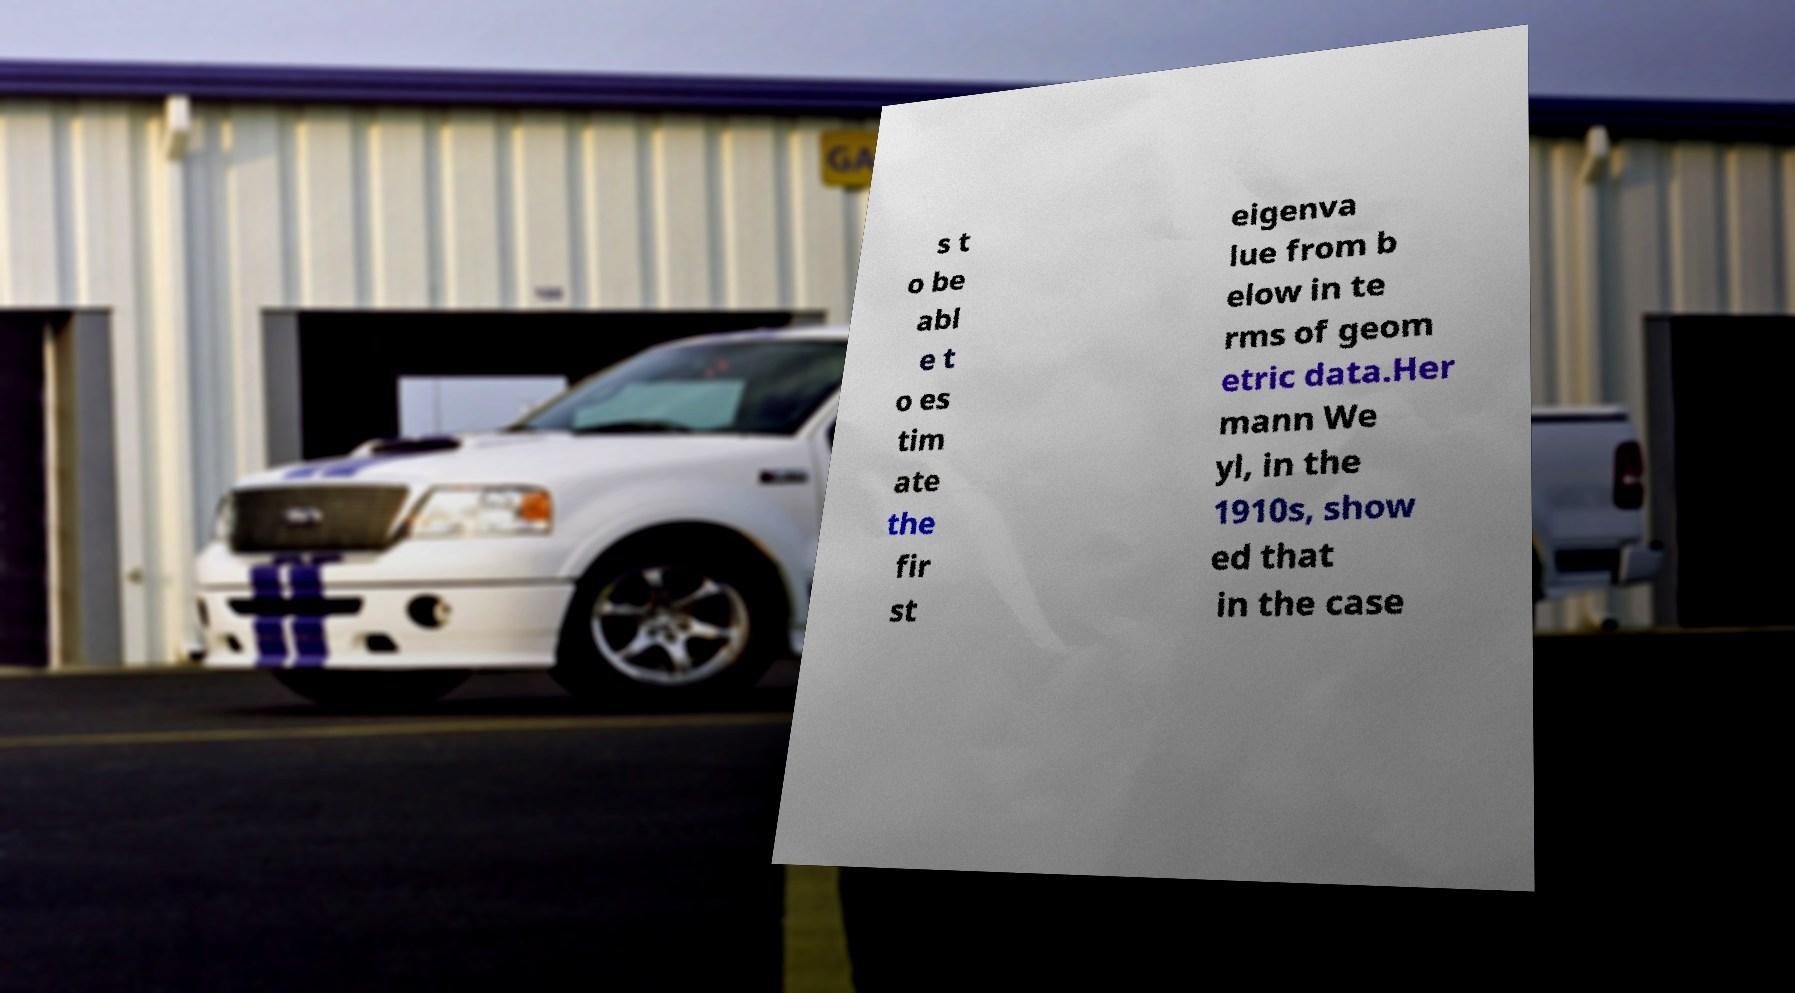Please identify and transcribe the text found in this image. s t o be abl e t o es tim ate the fir st eigenva lue from b elow in te rms of geom etric data.Her mann We yl, in the 1910s, show ed that in the case 